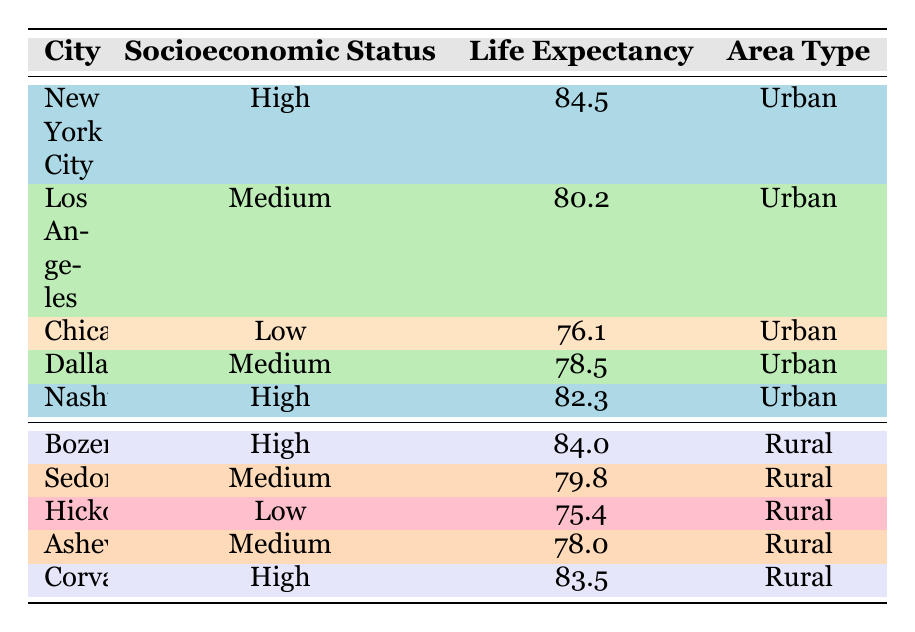What is the life expectancy of Nashville? The table has a row for Nashville, and under the life expectancy column, it states the value is 82.3.
Answer: 82.3 What is the average life expectancy for cities listed as Urban? First, identify the life expectancy values for Urban cities: 84.5 (New York City), 80.2 (Los Angeles), 76.1 (Chicago), 78.5 (Dallas), and 82.3 (Nashville). The sum is 84.5 + 80.2 + 76.1 + 78.5 + 82.3 = 401.6. There are 5 cities, so the average is 401.6 / 5 = 80.32.
Answer: 80.32 Does Chicago have a higher life expectancy than Hickory? Chicago's life expectancy is 76.1, and Hickory's is 75.4. Since 76.1 is greater than 75.4, the statement is true.
Answer: Yes What is the difference in life expectancy between the highest and lowest rural areas? The highest life expectancy in rural areas is 84.0 from Bozeman, and the lowest is 75.4 from Hickory. The difference is 84.0 - 75.4 = 8.6.
Answer: 8.6 Is the life expectancy for high socioeconomic status cities greater than that for medium status cities? First, find the life expectancy for high socioeconomic status cities: 84.5 (New York City), 82.3 (Nashville), 84.0 (Bozeman), and 83.5 (Corvallis) averaging to 83.575. Then for medium status: 80.2 (Los Angeles), 78.5 (Dallas), and 79.8 (Sedona), averaging to 79.5. Since 83.575 is greater than 79.5, the statement is true.
Answer: Yes What is the average life expectancy for rural areas? The life expectancy values for rural cities are 84.0 (Bozeman), 79.8 (Sedona), 75.4 (Hickory), 78.0 (Asheville), and 83.5 (Corvallis). Adding these gives 84.0 + 79.8 + 75.4 + 78.0 + 83.5 = 400.7. Dividing by 5 gives 400.7 / 5 = 80.14.
Answer: 80.14 